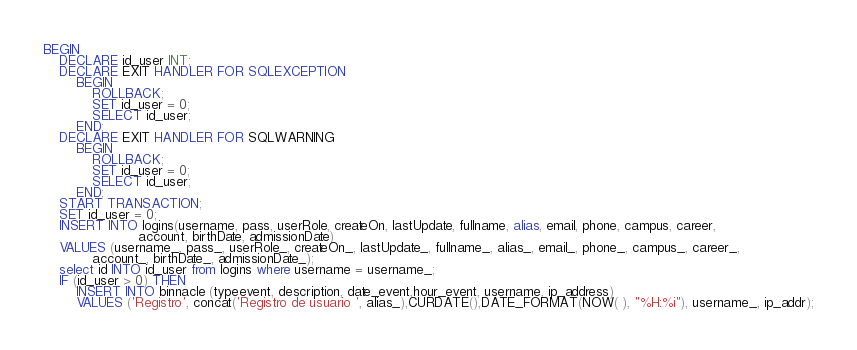Convert code to text. <code><loc_0><loc_0><loc_500><loc_500><_SQL_>BEGIN
    DECLARE id_user INT;
    DECLARE EXIT HANDLER FOR SQLEXCEPTION
        BEGIN
            ROLLBACK;
            SET id_user = 0;
            SELECT id_user;
        END;
    DECLARE EXIT HANDLER FOR SQLWARNING
        BEGIN
            ROLLBACK;
            SET id_user = 0;
            SELECT id_user;
        END;
    START TRANSACTION;
    SET id_user = 0;
    INSERT INTO logins(username, pass, userRole, createOn, lastUpdate, fullname, alias, email, phone, campus, career,
                       account, birthDate, admissionDate)
    VALUES (username_, pass_, userRole_, createOn_, lastUpdate_, fullname_, alias_, email_, phone_, campus_, career_,
            account_, birthDate_, admissionDate_);
    select id INTO id_user from logins where username = username_;
    IF (id_user > 0) THEN
        INSERT INTO binnacle (typeevent, description, date_event,hour_event, username, ip_address)
        VALUES ('Registro', concat('Registro de usuario ', alias_),CURDATE(),DATE_FORMAT(NOW( ), "%H:%i"), username_, ip_addr);</code> 